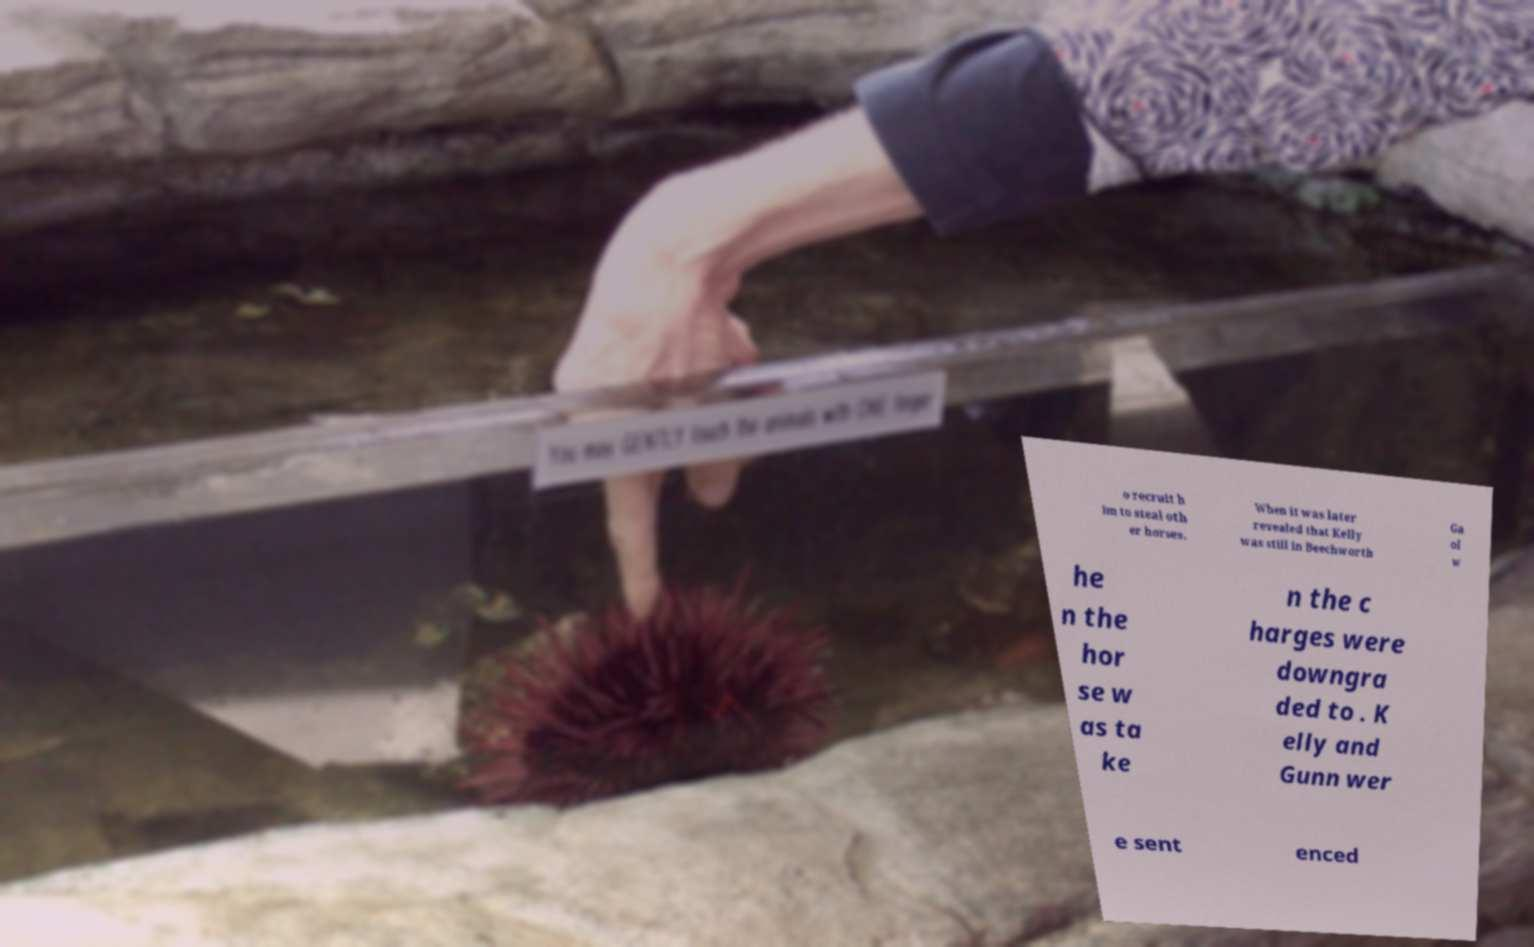What messages or text are displayed in this image? I need them in a readable, typed format. o recruit h im to steal oth er horses. When it was later revealed that Kelly was still in Beechworth Ga ol w he n the hor se w as ta ke n the c harges were downgra ded to . K elly and Gunn wer e sent enced 